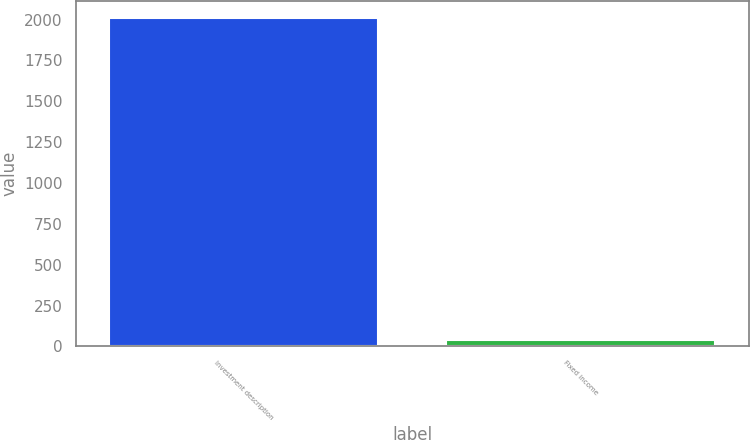Convert chart. <chart><loc_0><loc_0><loc_500><loc_500><bar_chart><fcel>Investment description<fcel>Fixed income<nl><fcel>2012<fcel>40<nl></chart> 